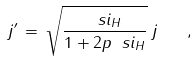Convert formula to latex. <formula><loc_0><loc_0><loc_500><loc_500>j ^ { \prime } \, = \, \sqrt { \frac { \ s i _ { H } } { 1 + 2 p \ s i _ { H } } } \, j \quad ,</formula> 